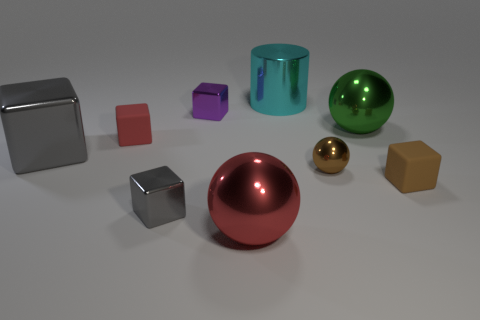What shape is the small thing that is the same color as the big cube?
Provide a short and direct response. Cube. There is a matte thing right of the large cyan shiny thing; is it the same shape as the small rubber thing on the left side of the big red object?
Your answer should be very brief. Yes. Is the number of brown metal balls that are to the right of the large cylinder the same as the number of big cylinders?
Ensure brevity in your answer.  Yes. Is there any other thing that is the same size as the cyan metallic cylinder?
Provide a short and direct response. Yes. There is a large gray object that is the same shape as the small red object; what is its material?
Give a very brief answer. Metal. What is the shape of the tiny rubber thing that is on the right side of the red thing in front of the large gray cube?
Your answer should be compact. Cube. Is the material of the ball that is left of the metallic cylinder the same as the small sphere?
Your response must be concise. Yes. Are there an equal number of purple blocks to the right of the big green object and blocks that are in front of the big metallic cube?
Your answer should be very brief. No. There is a object that is the same color as the big block; what is its material?
Your answer should be compact. Metal. There is a matte cube to the left of the metal cylinder; what number of matte objects are behind it?
Your answer should be very brief. 0. 